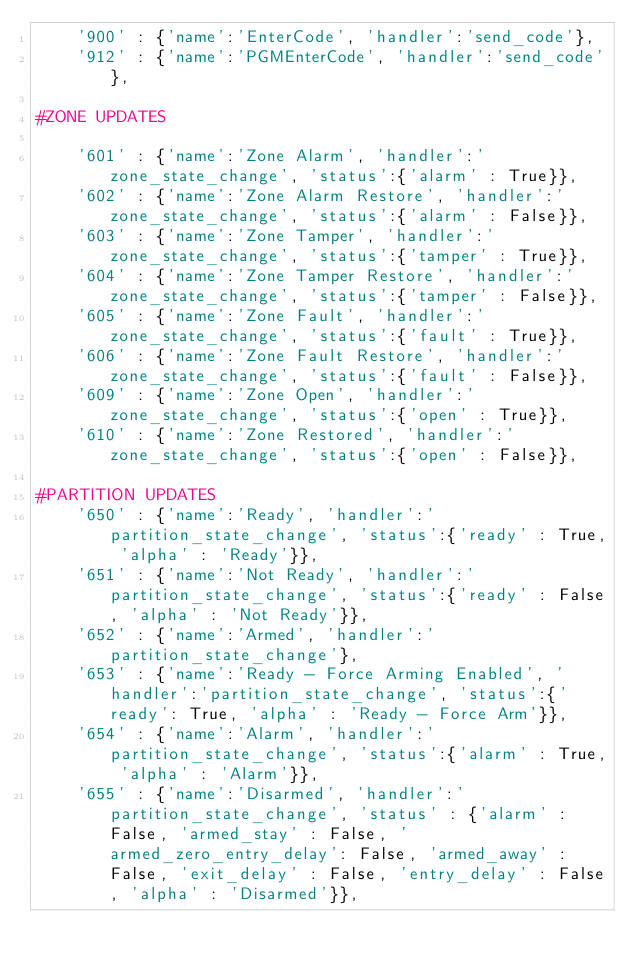Convert code to text. <code><loc_0><loc_0><loc_500><loc_500><_Python_>    '900' : {'name':'EnterCode', 'handler':'send_code'},
    '912' : {'name':'PGMEnterCode', 'handler':'send_code'},

#ZONE UPDATES

    '601' : {'name':'Zone Alarm', 'handler':'zone_state_change', 'status':{'alarm' : True}},
    '602' : {'name':'Zone Alarm Restore', 'handler':'zone_state_change', 'status':{'alarm' : False}},
    '603' : {'name':'Zone Tamper', 'handler':'zone_state_change', 'status':{'tamper' : True}},
    '604' : {'name':'Zone Tamper Restore', 'handler':'zone_state_change', 'status':{'tamper' : False}},
    '605' : {'name':'Zone Fault', 'handler':'zone_state_change', 'status':{'fault' : True}},
    '606' : {'name':'Zone Fault Restore', 'handler':'zone_state_change', 'status':{'fault' : False}},
    '609' : {'name':'Zone Open', 'handler':'zone_state_change', 'status':{'open' : True}},
    '610' : {'name':'Zone Restored', 'handler':'zone_state_change', 'status':{'open' : False}},

#PARTITION UPDATES
    '650' : {'name':'Ready', 'handler':'partition_state_change', 'status':{'ready' : True, 'alpha' : 'Ready'}},
    '651' : {'name':'Not Ready', 'handler':'partition_state_change', 'status':{'ready' : False, 'alpha' : 'Not Ready'}},
    '652' : {'name':'Armed', 'handler':'partition_state_change'},
    '653' : {'name':'Ready - Force Arming Enabled', 'handler':'partition_state_change', 'status':{'ready': True, 'alpha' : 'Ready - Force Arm'}},
    '654' : {'name':'Alarm', 'handler':'partition_state_change', 'status':{'alarm' : True, 'alpha' : 'Alarm'}},
    '655' : {'name':'Disarmed', 'handler':'partition_state_change', 'status' : {'alarm' : False, 'armed_stay' : False, 'armed_zero_entry_delay': False, 'armed_away' : False, 'exit_delay' : False, 'entry_delay' : False, 'alpha' : 'Disarmed'}},</code> 